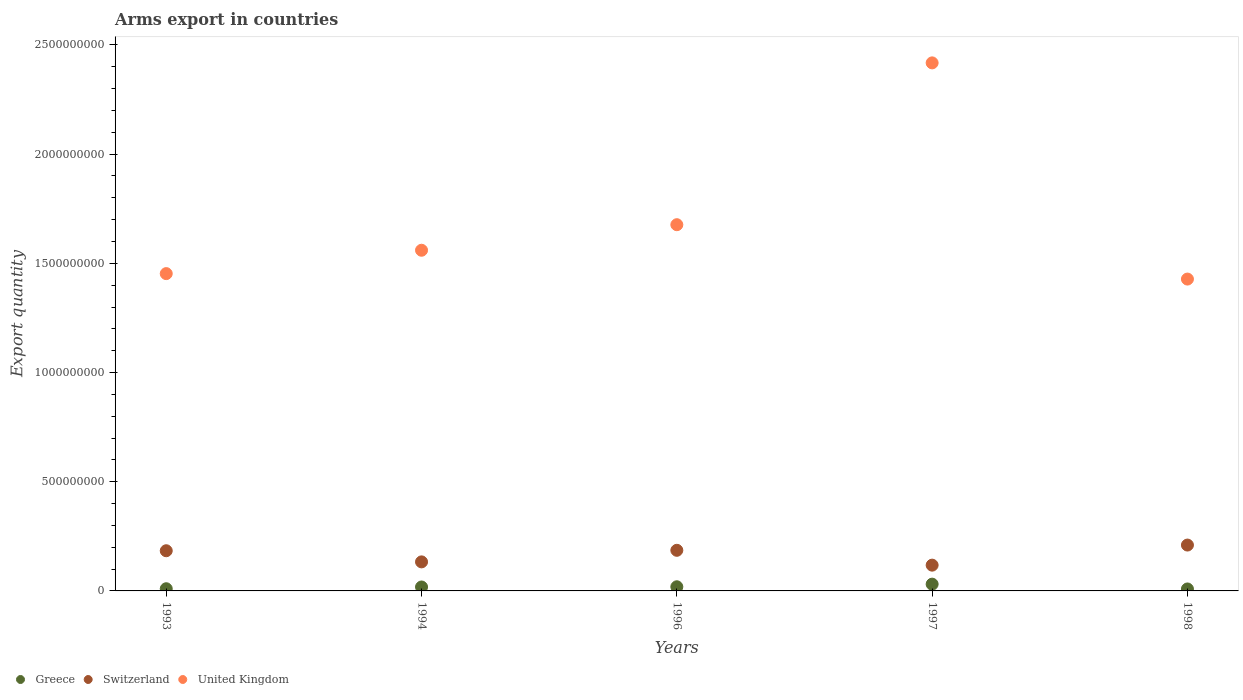What is the total arms export in United Kingdom in 1993?
Offer a very short reply. 1.45e+09. Across all years, what is the maximum total arms export in Switzerland?
Offer a very short reply. 2.10e+08. Across all years, what is the minimum total arms export in Switzerland?
Your answer should be very brief. 1.18e+08. In which year was the total arms export in United Kingdom maximum?
Your answer should be compact. 1997. In which year was the total arms export in United Kingdom minimum?
Your response must be concise. 1998. What is the total total arms export in United Kingdom in the graph?
Provide a short and direct response. 8.54e+09. What is the difference between the total arms export in Switzerland in 1994 and that in 1997?
Keep it short and to the point. 1.50e+07. What is the difference between the total arms export in Switzerland in 1998 and the total arms export in Greece in 1994?
Provide a short and direct response. 1.92e+08. What is the average total arms export in Switzerland per year?
Offer a very short reply. 1.66e+08. In the year 1996, what is the difference between the total arms export in Switzerland and total arms export in United Kingdom?
Keep it short and to the point. -1.49e+09. In how many years, is the total arms export in Greece greater than 700000000?
Your answer should be compact. 0. What is the ratio of the total arms export in Greece in 1993 to that in 1996?
Your response must be concise. 0.53. Is the total arms export in Switzerland in 1996 less than that in 1997?
Make the answer very short. No. Is the difference between the total arms export in Switzerland in 1993 and 1994 greater than the difference between the total arms export in United Kingdom in 1993 and 1994?
Your response must be concise. Yes. What is the difference between the highest and the second highest total arms export in United Kingdom?
Provide a succinct answer. 7.41e+08. What is the difference between the highest and the lowest total arms export in United Kingdom?
Make the answer very short. 9.90e+08. In how many years, is the total arms export in Greece greater than the average total arms export in Greece taken over all years?
Offer a very short reply. 3. Does the total arms export in Greece monotonically increase over the years?
Keep it short and to the point. No. Is the total arms export in Greece strictly less than the total arms export in Switzerland over the years?
Provide a succinct answer. Yes. How many dotlines are there?
Keep it short and to the point. 3. How many years are there in the graph?
Ensure brevity in your answer.  5. What is the difference between two consecutive major ticks on the Y-axis?
Keep it short and to the point. 5.00e+08. Does the graph contain any zero values?
Offer a terse response. No. Does the graph contain grids?
Keep it short and to the point. No. How many legend labels are there?
Offer a terse response. 3. What is the title of the graph?
Your response must be concise. Arms export in countries. Does "Russian Federation" appear as one of the legend labels in the graph?
Your answer should be very brief. No. What is the label or title of the X-axis?
Keep it short and to the point. Years. What is the label or title of the Y-axis?
Provide a succinct answer. Export quantity. What is the Export quantity in Switzerland in 1993?
Provide a succinct answer. 1.84e+08. What is the Export quantity in United Kingdom in 1993?
Give a very brief answer. 1.45e+09. What is the Export quantity in Greece in 1994?
Ensure brevity in your answer.  1.80e+07. What is the Export quantity of Switzerland in 1994?
Your answer should be very brief. 1.33e+08. What is the Export quantity in United Kingdom in 1994?
Give a very brief answer. 1.56e+09. What is the Export quantity of Greece in 1996?
Make the answer very short. 1.90e+07. What is the Export quantity in Switzerland in 1996?
Your response must be concise. 1.86e+08. What is the Export quantity in United Kingdom in 1996?
Offer a terse response. 1.68e+09. What is the Export quantity of Greece in 1997?
Your answer should be very brief. 3.10e+07. What is the Export quantity in Switzerland in 1997?
Your answer should be compact. 1.18e+08. What is the Export quantity of United Kingdom in 1997?
Offer a terse response. 2.42e+09. What is the Export quantity in Greece in 1998?
Provide a succinct answer. 9.00e+06. What is the Export quantity in Switzerland in 1998?
Give a very brief answer. 2.10e+08. What is the Export quantity in United Kingdom in 1998?
Your answer should be very brief. 1.43e+09. Across all years, what is the maximum Export quantity of Greece?
Your answer should be compact. 3.10e+07. Across all years, what is the maximum Export quantity of Switzerland?
Provide a short and direct response. 2.10e+08. Across all years, what is the maximum Export quantity of United Kingdom?
Provide a short and direct response. 2.42e+09. Across all years, what is the minimum Export quantity in Greece?
Provide a short and direct response. 9.00e+06. Across all years, what is the minimum Export quantity in Switzerland?
Ensure brevity in your answer.  1.18e+08. Across all years, what is the minimum Export quantity of United Kingdom?
Offer a terse response. 1.43e+09. What is the total Export quantity of Greece in the graph?
Your response must be concise. 8.70e+07. What is the total Export quantity in Switzerland in the graph?
Give a very brief answer. 8.31e+08. What is the total Export quantity of United Kingdom in the graph?
Provide a succinct answer. 8.54e+09. What is the difference between the Export quantity of Greece in 1993 and that in 1994?
Provide a short and direct response. -8.00e+06. What is the difference between the Export quantity of Switzerland in 1993 and that in 1994?
Offer a terse response. 5.10e+07. What is the difference between the Export quantity of United Kingdom in 1993 and that in 1994?
Your response must be concise. -1.07e+08. What is the difference between the Export quantity in Greece in 1993 and that in 1996?
Provide a succinct answer. -9.00e+06. What is the difference between the Export quantity in Switzerland in 1993 and that in 1996?
Offer a terse response. -2.00e+06. What is the difference between the Export quantity of United Kingdom in 1993 and that in 1996?
Your response must be concise. -2.24e+08. What is the difference between the Export quantity in Greece in 1993 and that in 1997?
Your answer should be compact. -2.10e+07. What is the difference between the Export quantity in Switzerland in 1993 and that in 1997?
Offer a very short reply. 6.60e+07. What is the difference between the Export quantity in United Kingdom in 1993 and that in 1997?
Ensure brevity in your answer.  -9.65e+08. What is the difference between the Export quantity in Greece in 1993 and that in 1998?
Provide a short and direct response. 1.00e+06. What is the difference between the Export quantity of Switzerland in 1993 and that in 1998?
Give a very brief answer. -2.60e+07. What is the difference between the Export quantity of United Kingdom in 1993 and that in 1998?
Ensure brevity in your answer.  2.50e+07. What is the difference between the Export quantity of Greece in 1994 and that in 1996?
Provide a succinct answer. -1.00e+06. What is the difference between the Export quantity of Switzerland in 1994 and that in 1996?
Offer a terse response. -5.30e+07. What is the difference between the Export quantity in United Kingdom in 1994 and that in 1996?
Keep it short and to the point. -1.17e+08. What is the difference between the Export quantity in Greece in 1994 and that in 1997?
Make the answer very short. -1.30e+07. What is the difference between the Export quantity in Switzerland in 1994 and that in 1997?
Offer a very short reply. 1.50e+07. What is the difference between the Export quantity in United Kingdom in 1994 and that in 1997?
Give a very brief answer. -8.58e+08. What is the difference between the Export quantity of Greece in 1994 and that in 1998?
Keep it short and to the point. 9.00e+06. What is the difference between the Export quantity in Switzerland in 1994 and that in 1998?
Your response must be concise. -7.70e+07. What is the difference between the Export quantity in United Kingdom in 1994 and that in 1998?
Provide a succinct answer. 1.32e+08. What is the difference between the Export quantity of Greece in 1996 and that in 1997?
Your response must be concise. -1.20e+07. What is the difference between the Export quantity in Switzerland in 1996 and that in 1997?
Give a very brief answer. 6.80e+07. What is the difference between the Export quantity of United Kingdom in 1996 and that in 1997?
Offer a very short reply. -7.41e+08. What is the difference between the Export quantity in Greece in 1996 and that in 1998?
Provide a succinct answer. 1.00e+07. What is the difference between the Export quantity of Switzerland in 1996 and that in 1998?
Provide a short and direct response. -2.40e+07. What is the difference between the Export quantity of United Kingdom in 1996 and that in 1998?
Provide a short and direct response. 2.49e+08. What is the difference between the Export quantity in Greece in 1997 and that in 1998?
Provide a short and direct response. 2.20e+07. What is the difference between the Export quantity in Switzerland in 1997 and that in 1998?
Provide a short and direct response. -9.20e+07. What is the difference between the Export quantity of United Kingdom in 1997 and that in 1998?
Offer a terse response. 9.90e+08. What is the difference between the Export quantity of Greece in 1993 and the Export quantity of Switzerland in 1994?
Your response must be concise. -1.23e+08. What is the difference between the Export quantity in Greece in 1993 and the Export quantity in United Kingdom in 1994?
Your response must be concise. -1.55e+09. What is the difference between the Export quantity of Switzerland in 1993 and the Export quantity of United Kingdom in 1994?
Your response must be concise. -1.38e+09. What is the difference between the Export quantity of Greece in 1993 and the Export quantity of Switzerland in 1996?
Offer a very short reply. -1.76e+08. What is the difference between the Export quantity of Greece in 1993 and the Export quantity of United Kingdom in 1996?
Make the answer very short. -1.67e+09. What is the difference between the Export quantity in Switzerland in 1993 and the Export quantity in United Kingdom in 1996?
Your response must be concise. -1.49e+09. What is the difference between the Export quantity of Greece in 1993 and the Export quantity of Switzerland in 1997?
Make the answer very short. -1.08e+08. What is the difference between the Export quantity in Greece in 1993 and the Export quantity in United Kingdom in 1997?
Make the answer very short. -2.41e+09. What is the difference between the Export quantity of Switzerland in 1993 and the Export quantity of United Kingdom in 1997?
Keep it short and to the point. -2.23e+09. What is the difference between the Export quantity of Greece in 1993 and the Export quantity of Switzerland in 1998?
Keep it short and to the point. -2.00e+08. What is the difference between the Export quantity of Greece in 1993 and the Export quantity of United Kingdom in 1998?
Your answer should be very brief. -1.42e+09. What is the difference between the Export quantity of Switzerland in 1993 and the Export quantity of United Kingdom in 1998?
Ensure brevity in your answer.  -1.24e+09. What is the difference between the Export quantity of Greece in 1994 and the Export quantity of Switzerland in 1996?
Your answer should be very brief. -1.68e+08. What is the difference between the Export quantity of Greece in 1994 and the Export quantity of United Kingdom in 1996?
Make the answer very short. -1.66e+09. What is the difference between the Export quantity of Switzerland in 1994 and the Export quantity of United Kingdom in 1996?
Your response must be concise. -1.54e+09. What is the difference between the Export quantity of Greece in 1994 and the Export quantity of Switzerland in 1997?
Ensure brevity in your answer.  -1.00e+08. What is the difference between the Export quantity in Greece in 1994 and the Export quantity in United Kingdom in 1997?
Ensure brevity in your answer.  -2.40e+09. What is the difference between the Export quantity in Switzerland in 1994 and the Export quantity in United Kingdom in 1997?
Your response must be concise. -2.28e+09. What is the difference between the Export quantity in Greece in 1994 and the Export quantity in Switzerland in 1998?
Ensure brevity in your answer.  -1.92e+08. What is the difference between the Export quantity in Greece in 1994 and the Export quantity in United Kingdom in 1998?
Offer a very short reply. -1.41e+09. What is the difference between the Export quantity in Switzerland in 1994 and the Export quantity in United Kingdom in 1998?
Ensure brevity in your answer.  -1.30e+09. What is the difference between the Export quantity of Greece in 1996 and the Export quantity of Switzerland in 1997?
Your answer should be compact. -9.90e+07. What is the difference between the Export quantity in Greece in 1996 and the Export quantity in United Kingdom in 1997?
Your response must be concise. -2.40e+09. What is the difference between the Export quantity in Switzerland in 1996 and the Export quantity in United Kingdom in 1997?
Your answer should be very brief. -2.23e+09. What is the difference between the Export quantity of Greece in 1996 and the Export quantity of Switzerland in 1998?
Offer a very short reply. -1.91e+08. What is the difference between the Export quantity in Greece in 1996 and the Export quantity in United Kingdom in 1998?
Make the answer very short. -1.41e+09. What is the difference between the Export quantity in Switzerland in 1996 and the Export quantity in United Kingdom in 1998?
Ensure brevity in your answer.  -1.24e+09. What is the difference between the Export quantity of Greece in 1997 and the Export quantity of Switzerland in 1998?
Offer a terse response. -1.79e+08. What is the difference between the Export quantity of Greece in 1997 and the Export quantity of United Kingdom in 1998?
Offer a terse response. -1.40e+09. What is the difference between the Export quantity of Switzerland in 1997 and the Export quantity of United Kingdom in 1998?
Provide a succinct answer. -1.31e+09. What is the average Export quantity of Greece per year?
Your answer should be compact. 1.74e+07. What is the average Export quantity of Switzerland per year?
Your answer should be compact. 1.66e+08. What is the average Export quantity in United Kingdom per year?
Give a very brief answer. 1.71e+09. In the year 1993, what is the difference between the Export quantity of Greece and Export quantity of Switzerland?
Keep it short and to the point. -1.74e+08. In the year 1993, what is the difference between the Export quantity of Greece and Export quantity of United Kingdom?
Provide a short and direct response. -1.44e+09. In the year 1993, what is the difference between the Export quantity of Switzerland and Export quantity of United Kingdom?
Offer a very short reply. -1.27e+09. In the year 1994, what is the difference between the Export quantity in Greece and Export quantity in Switzerland?
Provide a short and direct response. -1.15e+08. In the year 1994, what is the difference between the Export quantity of Greece and Export quantity of United Kingdom?
Make the answer very short. -1.54e+09. In the year 1994, what is the difference between the Export quantity of Switzerland and Export quantity of United Kingdom?
Provide a succinct answer. -1.43e+09. In the year 1996, what is the difference between the Export quantity of Greece and Export quantity of Switzerland?
Keep it short and to the point. -1.67e+08. In the year 1996, what is the difference between the Export quantity of Greece and Export quantity of United Kingdom?
Ensure brevity in your answer.  -1.66e+09. In the year 1996, what is the difference between the Export quantity of Switzerland and Export quantity of United Kingdom?
Keep it short and to the point. -1.49e+09. In the year 1997, what is the difference between the Export quantity of Greece and Export quantity of Switzerland?
Keep it short and to the point. -8.70e+07. In the year 1997, what is the difference between the Export quantity in Greece and Export quantity in United Kingdom?
Provide a short and direct response. -2.39e+09. In the year 1997, what is the difference between the Export quantity in Switzerland and Export quantity in United Kingdom?
Ensure brevity in your answer.  -2.30e+09. In the year 1998, what is the difference between the Export quantity of Greece and Export quantity of Switzerland?
Your answer should be compact. -2.01e+08. In the year 1998, what is the difference between the Export quantity of Greece and Export quantity of United Kingdom?
Offer a terse response. -1.42e+09. In the year 1998, what is the difference between the Export quantity of Switzerland and Export quantity of United Kingdom?
Your response must be concise. -1.22e+09. What is the ratio of the Export quantity in Greece in 1993 to that in 1994?
Make the answer very short. 0.56. What is the ratio of the Export quantity in Switzerland in 1993 to that in 1994?
Ensure brevity in your answer.  1.38. What is the ratio of the Export quantity in United Kingdom in 1993 to that in 1994?
Give a very brief answer. 0.93. What is the ratio of the Export quantity of Greece in 1993 to that in 1996?
Offer a terse response. 0.53. What is the ratio of the Export quantity of United Kingdom in 1993 to that in 1996?
Provide a succinct answer. 0.87. What is the ratio of the Export quantity in Greece in 1993 to that in 1997?
Offer a very short reply. 0.32. What is the ratio of the Export quantity of Switzerland in 1993 to that in 1997?
Ensure brevity in your answer.  1.56. What is the ratio of the Export quantity of United Kingdom in 1993 to that in 1997?
Offer a terse response. 0.6. What is the ratio of the Export quantity in Switzerland in 1993 to that in 1998?
Your response must be concise. 0.88. What is the ratio of the Export quantity of United Kingdom in 1993 to that in 1998?
Offer a terse response. 1.02. What is the ratio of the Export quantity of Switzerland in 1994 to that in 1996?
Ensure brevity in your answer.  0.72. What is the ratio of the Export quantity of United Kingdom in 1994 to that in 1996?
Offer a terse response. 0.93. What is the ratio of the Export quantity of Greece in 1994 to that in 1997?
Your answer should be compact. 0.58. What is the ratio of the Export quantity of Switzerland in 1994 to that in 1997?
Give a very brief answer. 1.13. What is the ratio of the Export quantity of United Kingdom in 1994 to that in 1997?
Give a very brief answer. 0.65. What is the ratio of the Export quantity in Switzerland in 1994 to that in 1998?
Your response must be concise. 0.63. What is the ratio of the Export quantity of United Kingdom in 1994 to that in 1998?
Keep it short and to the point. 1.09. What is the ratio of the Export quantity in Greece in 1996 to that in 1997?
Your answer should be compact. 0.61. What is the ratio of the Export quantity of Switzerland in 1996 to that in 1997?
Give a very brief answer. 1.58. What is the ratio of the Export quantity of United Kingdom in 1996 to that in 1997?
Your answer should be compact. 0.69. What is the ratio of the Export quantity in Greece in 1996 to that in 1998?
Your answer should be very brief. 2.11. What is the ratio of the Export quantity of Switzerland in 1996 to that in 1998?
Give a very brief answer. 0.89. What is the ratio of the Export quantity in United Kingdom in 1996 to that in 1998?
Provide a succinct answer. 1.17. What is the ratio of the Export quantity in Greece in 1997 to that in 1998?
Offer a terse response. 3.44. What is the ratio of the Export quantity of Switzerland in 1997 to that in 1998?
Your answer should be very brief. 0.56. What is the ratio of the Export quantity in United Kingdom in 1997 to that in 1998?
Offer a terse response. 1.69. What is the difference between the highest and the second highest Export quantity in Greece?
Offer a terse response. 1.20e+07. What is the difference between the highest and the second highest Export quantity in Switzerland?
Provide a succinct answer. 2.40e+07. What is the difference between the highest and the second highest Export quantity in United Kingdom?
Make the answer very short. 7.41e+08. What is the difference between the highest and the lowest Export quantity of Greece?
Offer a very short reply. 2.20e+07. What is the difference between the highest and the lowest Export quantity of Switzerland?
Your response must be concise. 9.20e+07. What is the difference between the highest and the lowest Export quantity of United Kingdom?
Your answer should be very brief. 9.90e+08. 